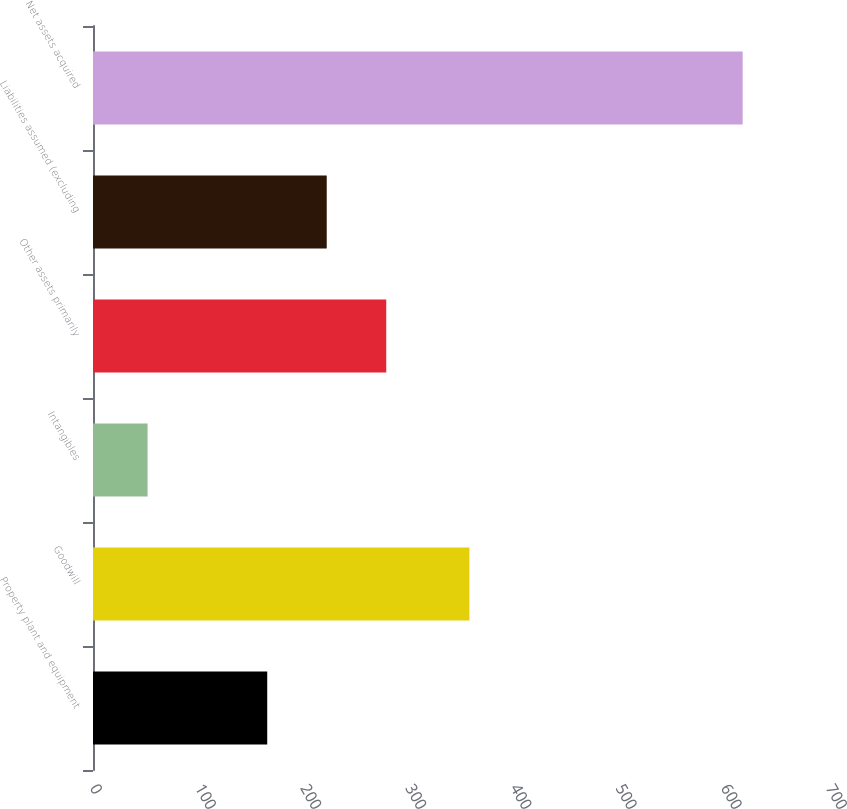Convert chart. <chart><loc_0><loc_0><loc_500><loc_500><bar_chart><fcel>Property plant and equipment<fcel>Goodwill<fcel>Intangibles<fcel>Other assets primarily<fcel>Liabilities assumed (excluding<fcel>Net assets acquired<nl><fcel>165.7<fcel>358<fcel>51.9<fcel>278.9<fcel>222.3<fcel>617.9<nl></chart> 